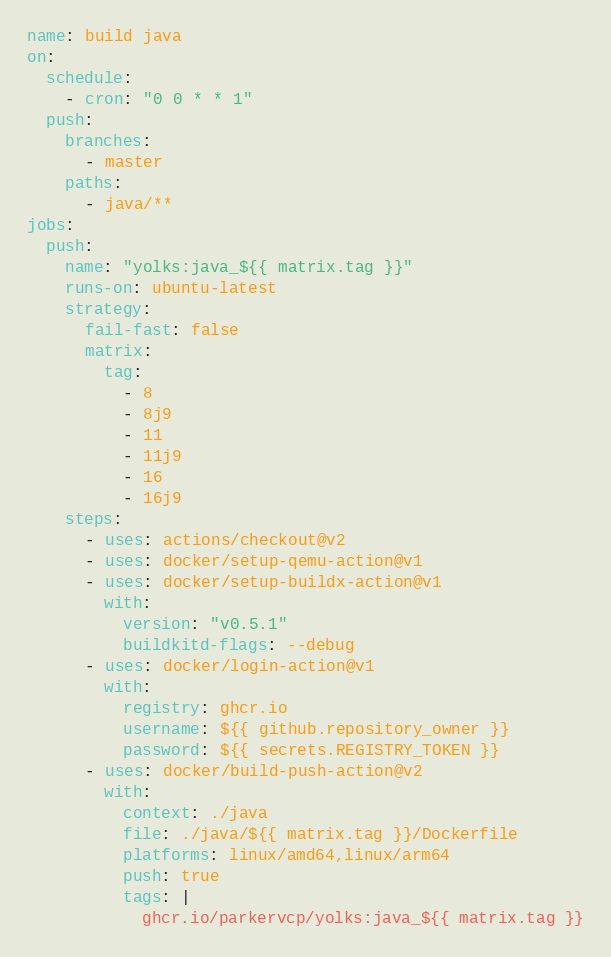Convert code to text. <code><loc_0><loc_0><loc_500><loc_500><_YAML_>name: build java
on:
  schedule:
    - cron: "0 0 * * 1"
  push:
    branches:
      - master
    paths:
      - java/**
jobs:
  push:
    name: "yolks:java_${{ matrix.tag }}"
    runs-on: ubuntu-latest
    strategy:
      fail-fast: false
      matrix:
        tag:
          - 8
          - 8j9
          - 11
          - 11j9
          - 16
          - 16j9
    steps:
      - uses: actions/checkout@v2
      - uses: docker/setup-qemu-action@v1
      - uses: docker/setup-buildx-action@v1
        with:
          version: "v0.5.1"
          buildkitd-flags: --debug
      - uses: docker/login-action@v1
        with:
          registry: ghcr.io
          username: ${{ github.repository_owner }}
          password: ${{ secrets.REGISTRY_TOKEN }}
      - uses: docker/build-push-action@v2
        with:
          context: ./java
          file: ./java/${{ matrix.tag }}/Dockerfile
          platforms: linux/amd64,linux/arm64
          push: true
          tags: |
            ghcr.io/parkervcp/yolks:java_${{ matrix.tag }}</code> 